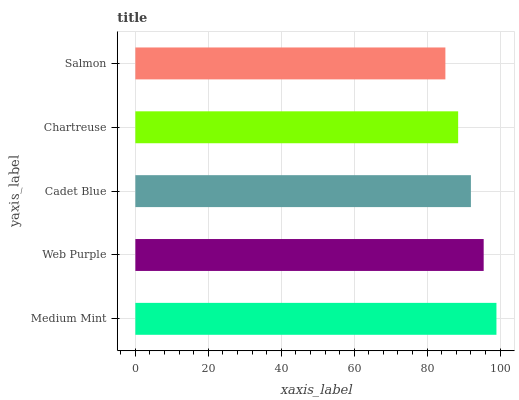Is Salmon the minimum?
Answer yes or no. Yes. Is Medium Mint the maximum?
Answer yes or no. Yes. Is Web Purple the minimum?
Answer yes or no. No. Is Web Purple the maximum?
Answer yes or no. No. Is Medium Mint greater than Web Purple?
Answer yes or no. Yes. Is Web Purple less than Medium Mint?
Answer yes or no. Yes. Is Web Purple greater than Medium Mint?
Answer yes or no. No. Is Medium Mint less than Web Purple?
Answer yes or no. No. Is Cadet Blue the high median?
Answer yes or no. Yes. Is Cadet Blue the low median?
Answer yes or no. Yes. Is Medium Mint the high median?
Answer yes or no. No. Is Salmon the low median?
Answer yes or no. No. 